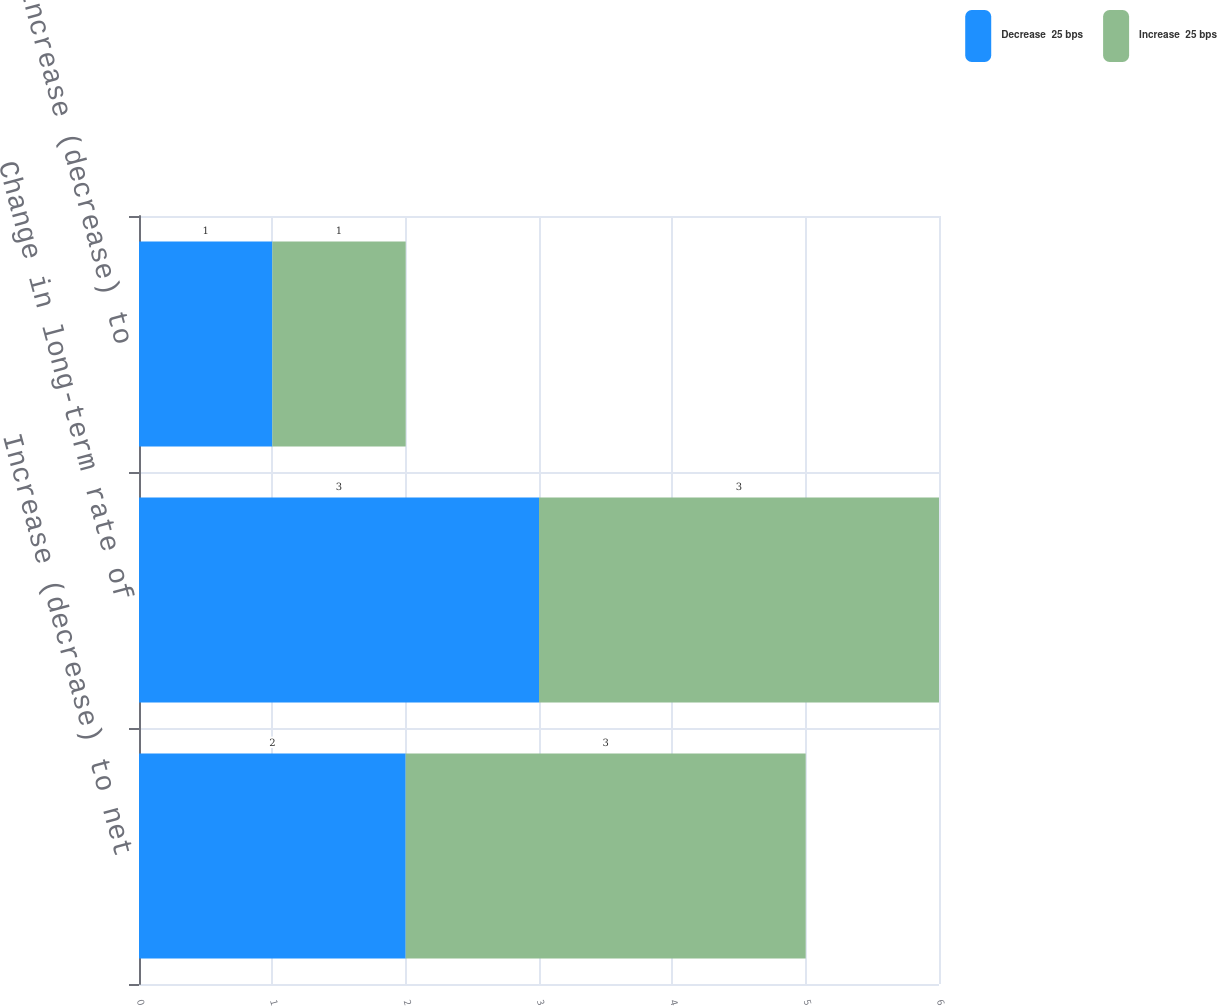Convert chart. <chart><loc_0><loc_0><loc_500><loc_500><stacked_bar_chart><ecel><fcel>Increase (decrease) to net<fcel>Change in long-term rate of<fcel>Increase (decrease) to<nl><fcel>Decrease  25 bps<fcel>2<fcel>3<fcel>1<nl><fcel>Increase  25 bps<fcel>3<fcel>3<fcel>1<nl></chart> 